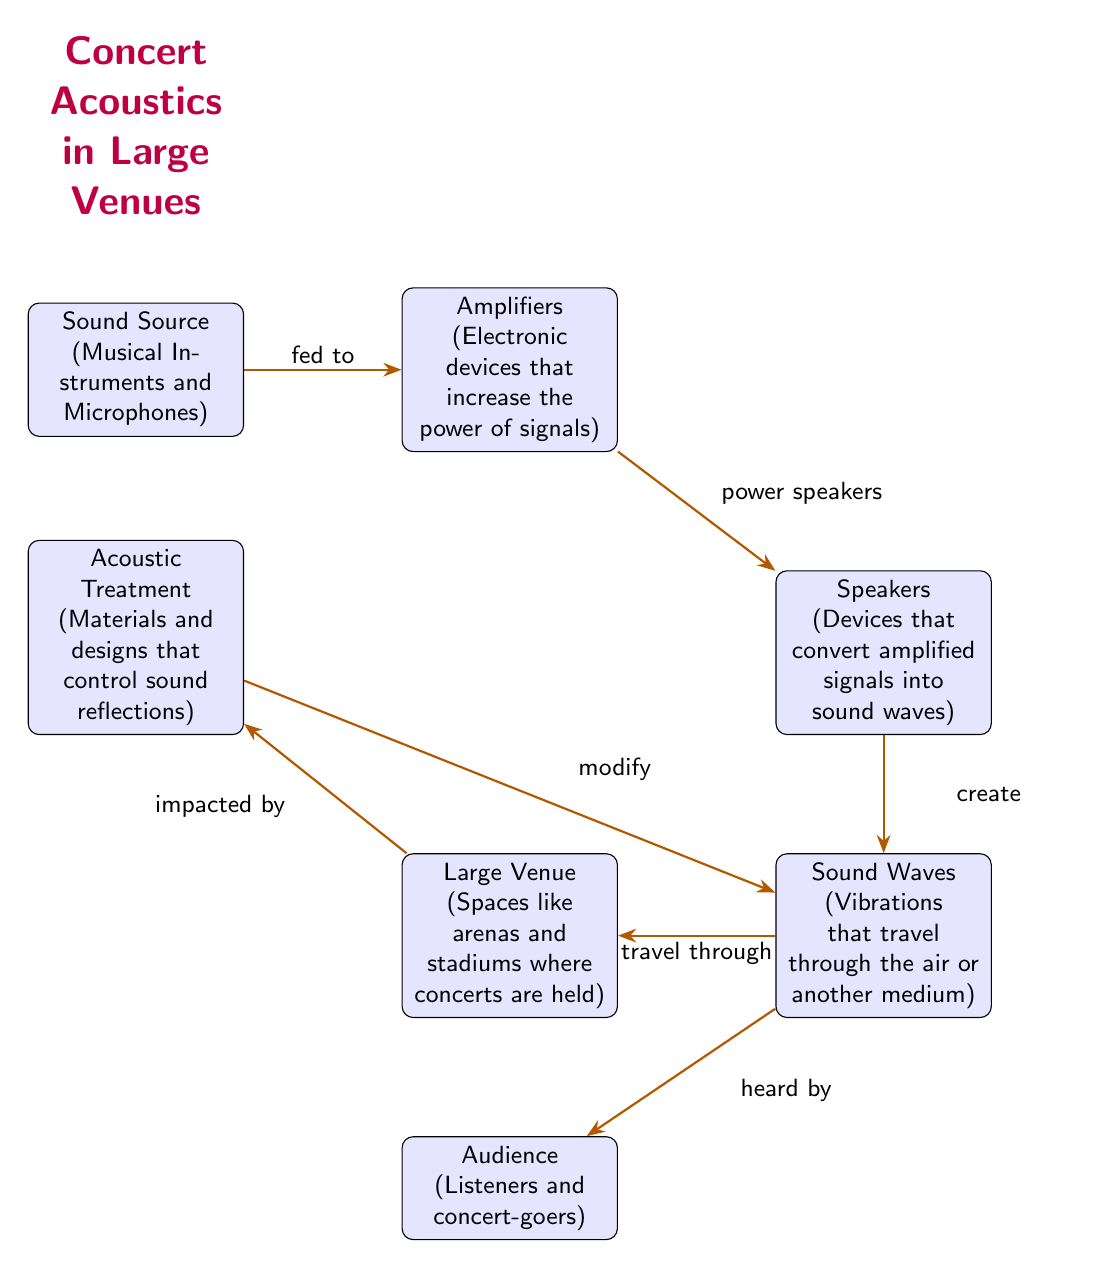What is the sound source in the diagram? The first box in the diagram, labeled "Sound Source", identifies what produces the sound in a concert, which includes musical instruments and microphones.
Answer: Sound Source (Musical Instruments and Microphones) How many nodes are depicted in the diagram? By counting all the individual boxes in the diagram, we can see there are seven labeled nodes outlining the concert acoustics process.
Answer: 7 What device is used to increase the power of signals? The second box labeled "Amplifiers" is responsible for boosting the power of the audio signals before they are sent to the speakers.
Answer: Amplifiers (Electronic devices that increase the power of signals) What travels through the air in a concert venue? The arrow pointing from "Sound Waves" to "Large Venue" indicates that sound waves are the vibrations that move through the air in concert settings.
Answer: Sound Waves (Vibrations that travel through the air or another medium) What impacts acoustics in large venues? The connection between the "Large Venue" node and the "Acoustic Treatment" node shows that the venue's design and materials affect how sound behaves.
Answer: Acoustic Treatment (Materials and designs that control sound reflections) What are sound waves created by? The arrow from "Speakers" to "Sound Waves" demonstrates that when speakers function, they create sound waves as a result of converting the amplified signals.
Answer: create How do acoustic treatments modify sound waves? The diagram shows a direct relationship where the "Acoustic Treatment" impacts the "Sound Waves," meaning the materials alter how the sound waves behave before reaching the audience.
Answer: modify Who are the recipients of the sound waves in the concert? The diagram indicates that the "Audience" node is where sound waves are directed, meaning concert-goers are the ones hearing the sound produced.
Answer: Audience (Listeners and concert-goers) What is the flow of sound from the source to the audience? Following the arrows from the "Sound Source" to "Amplifiers," then to "Speakers," then to "Sound Waves," and finally to the "Audience" shows the sequence in which sound is transmitted to concert attendees.
Answer: Sound Source → Amplifiers → Speakers → Sound Waves → Audience What does the acoustic treatment control? The diagram illustrates that "Acoustic Treatment" modifies the sound waves as they travel, highlighting its role in controlling reflections and enhancing sound quality.
Answer: sound reflections 